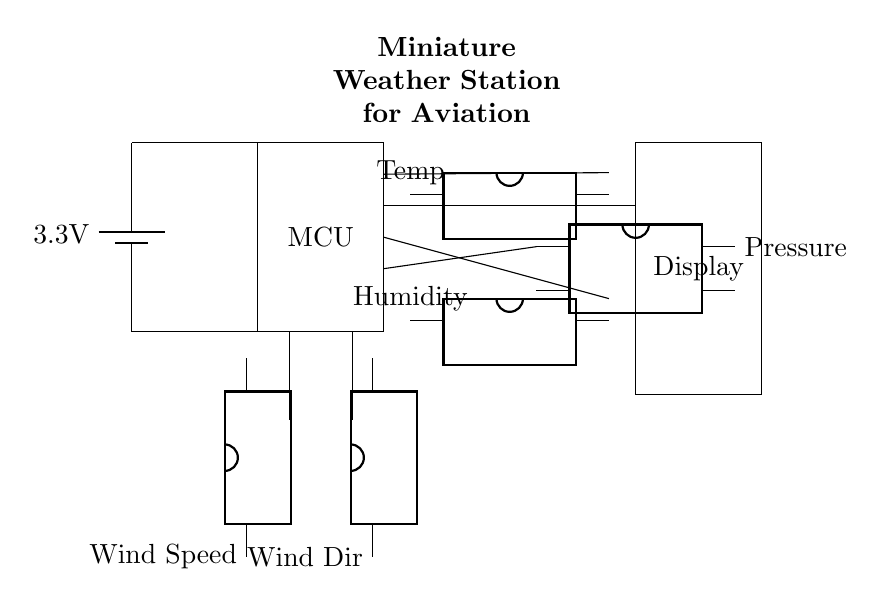What is the main voltage supply for this circuit? The circuit is powered by a battery, which is labeled as providing 3.3 volts. This is indicated by the battery symbol connected at the top left of the diagram.
Answer: 3.3 volts What components are used for measuring environmental conditions? The circuit includes several sensors: a temperature sensor, a humidity sensor, a pressure sensor, a wind speed sensor, and a wind direction sensor. Each sensor is represented by a dip chip icon labeled accordingly.
Answer: Temperature, humidity, pressure, wind speed, wind direction sensors Which component is responsible for displaying the monitored data? The display component is shown as a rectangle labeled "Display" at the bottom right of the circuit diagram. This implies that it takes readings from the sensors and shows them to the user.
Answer: Display How many sensors are directly connected to the microcontroller? The diagram shows a total of five sensors connected to the microcontroller. Each sensor has a line drawn to the MCU, indicating they send data for processing.
Answer: Five What is the role of the microcontroller in this circuit? The microcontroller (MCU) acts as the central processing unit in this circuit, processing the data received from the various sensors and possibly sending it to the display. It is the main component that orchestrates the operation of other devices in the circuit.
Answer: Central processing What type of sensors are used in this miniature weather station? The sensors used in the circuit are electronic sensors, each designed to measure specific environmental parameters such as temperature, humidity, pressure, wind speed, and wind direction. These use electrical changes to provide accurate readings.
Answer: Electronic sensors What is the orientation of the wind speed and wind direction sensors? The wind speed and wind direction sensors are oriented vertically, as indicated by their placement and the directions of their labels in the circuit. This orientation may enhance their ability to accurately measure wind conditions.
Answer: Vertical 